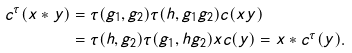<formula> <loc_0><loc_0><loc_500><loc_500>c ^ { \tau } ( x * y ) & = \tau ( g _ { 1 } , g _ { 2 } ) \tau ( h , g _ { 1 } g _ { 2 } ) c ( x y ) \\ & = \tau ( h , g _ { 2 } ) \tau ( g _ { 1 } , h g _ { 2 } ) x c ( y ) = x * c ^ { \tau } ( y ) .</formula> 